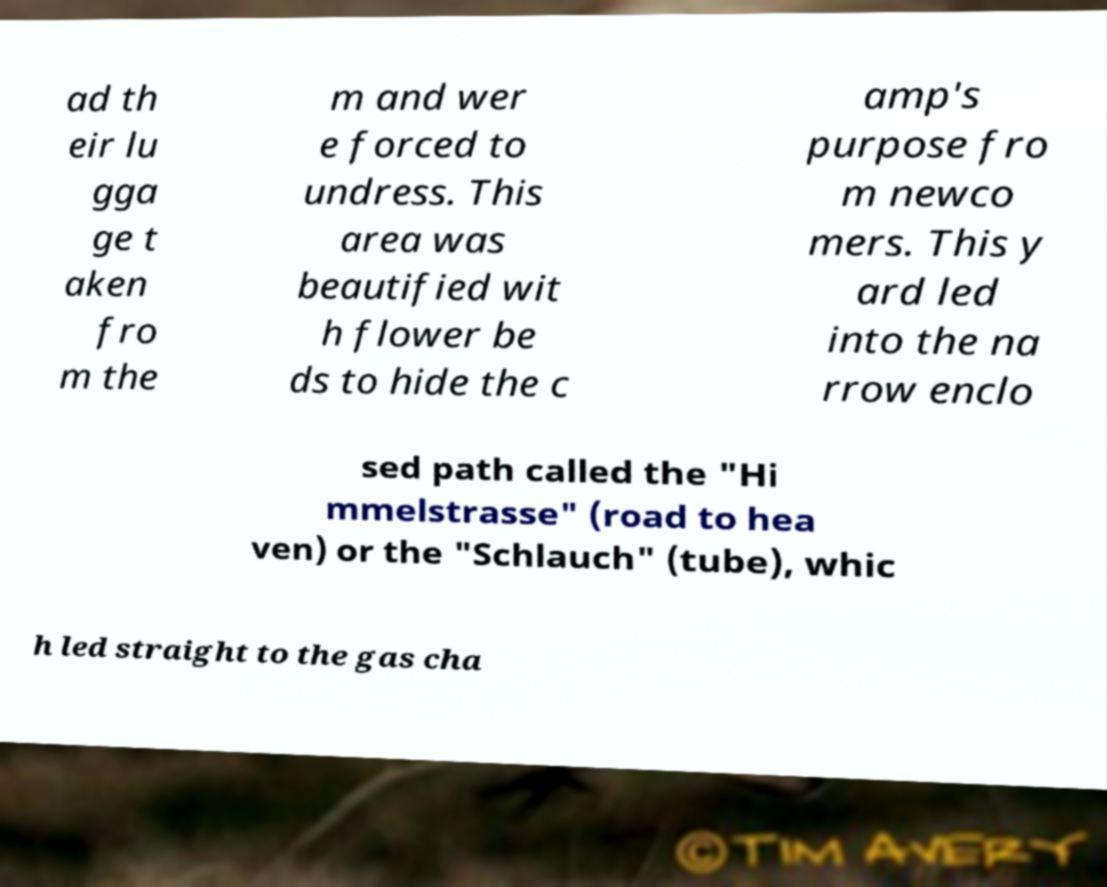Can you accurately transcribe the text from the provided image for me? ad th eir lu gga ge t aken fro m the m and wer e forced to undress. This area was beautified wit h flower be ds to hide the c amp's purpose fro m newco mers. This y ard led into the na rrow enclo sed path called the "Hi mmelstrasse" (road to hea ven) or the "Schlauch" (tube), whic h led straight to the gas cha 